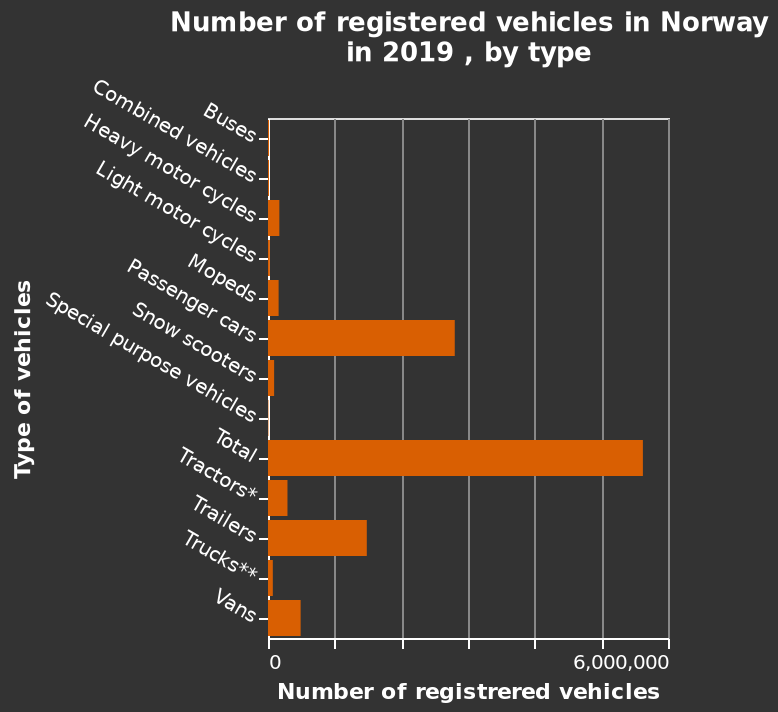<image>
What year does the bar diagram represent? The bar diagram represents the number of registered vehicles in Norway in 2019. How many passenger cars are registered? The exact number of registered passenger cars is not provided in the description. What does the y-axis represent in the bar diagram? The y-axis represents the type of vehicles. 